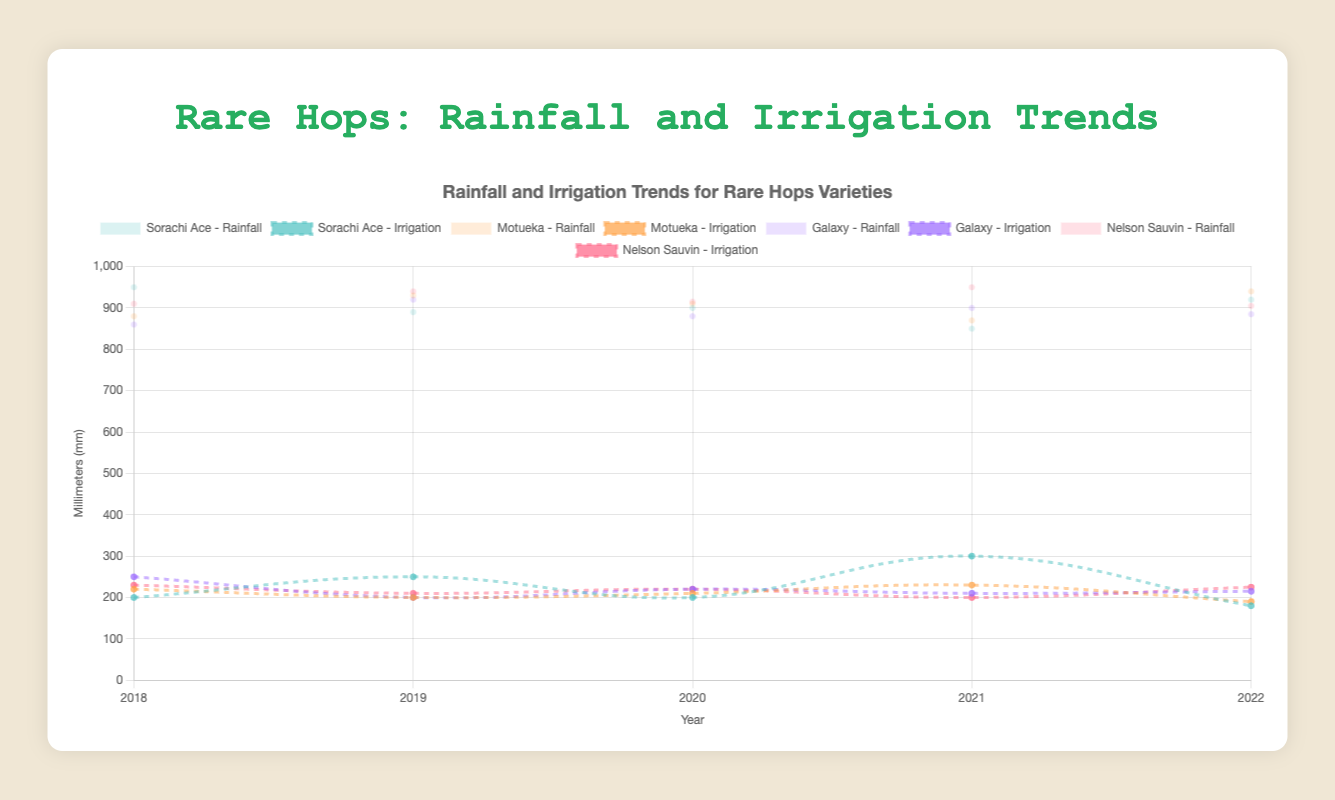What variety had the lowest rainfall in 2021? Look at the rainfall trends for each hops variety in 2021. Sorachi Ace had 850 mm which is the lowest compared to others.
Answer: Sorachi Ace Which variety experienced the highest irrigation needed in 2022? Look at the irrigation trends for each hops variety in 2022. Sorachi Ace needed 180 mm which is the highest compared to others.
Answer: Sorachi Ace Was there an increase or decrease in rainfall for the variety "Galaxy" from 2019 to 2020? Compare the rainfall for Galaxy in 2019 (920 mm) and 2020 (880 mm). There was a decrease in rainfall.
Answer: Decrease Which year required the most irrigation for "Motueka"? Look at the irrigation trends over years for Motueka and find the maximum value. In 2018, irrigation needed was 220 mm which is the highest.
Answer: 2018 What is the total rainfall for "Nelson Sauvin" over the 5 years? Sum the rainfall for Nelson Sauvin over the years: 2018 (910 mm) + 2019 (940 mm) + 2020 (915 mm) + 2021 (950 mm) + 2022 (905 mm). Total is 4620 mm.
Answer: 4620 mm In which year did "Sorachi Ace" need the least irrigation? Look at the irrigation trends over years for Sorachi Ace and find the minimum value. In 2022, it needed only 180 mm, which is the least.
Answer: 2022 Calculate the average rainfall for "Motueka" over the 5 years. Sum the rainfall for Motueka over the years: 2018 (880 mm) + 2019 (930 mm) + 2020 (910 mm) + 2021 (870 mm) + 2022 (940 mm) and divide by 5 to get the average. Total is 4530 mm, so the average is 906 mm
Answer: 906 mm Is the trend of irrigation needs for "Galaxy" increasing or decreasing over the 5 years? Observe the irrigation needed for Galaxy from 2018 to 2022 (250 mm, 200 mm, 220 mm, 210 mm, 215 mm respectively). It is slightly decreasing over time but has minor fluctuations.
Answer: Decreasing 